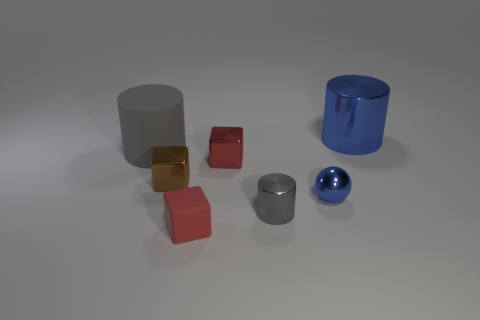Add 3 blue cylinders. How many objects exist? 10 Subtract all cubes. How many objects are left? 4 Add 1 gray matte cylinders. How many gray matte cylinders are left? 2 Add 3 big gray objects. How many big gray objects exist? 4 Subtract 0 yellow cylinders. How many objects are left? 7 Subtract all big purple metal blocks. Subtract all gray matte objects. How many objects are left? 6 